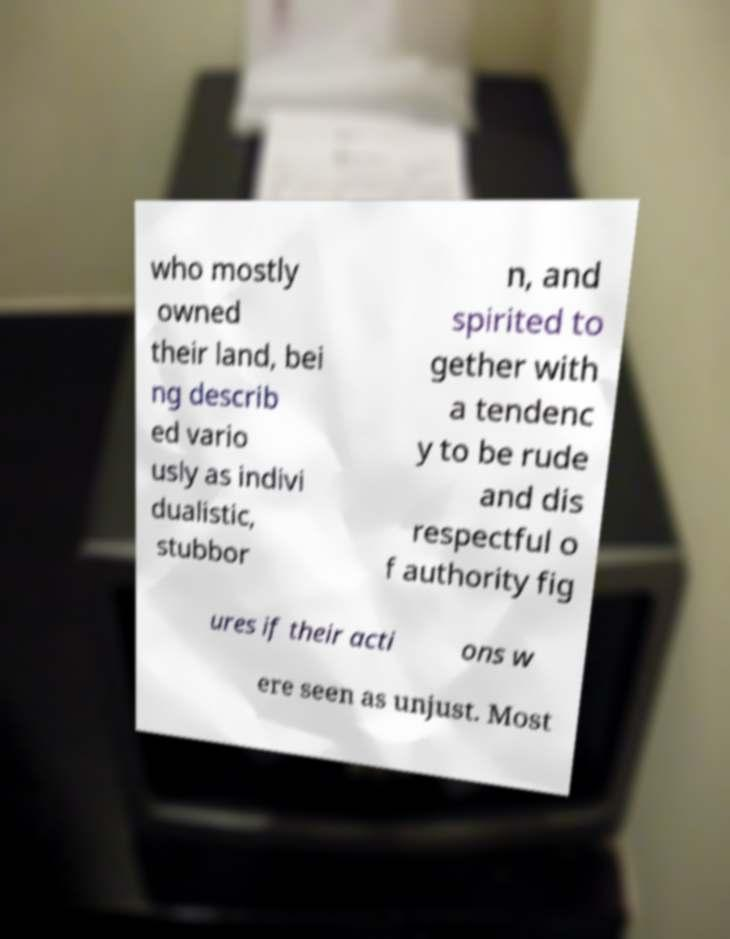What messages or text are displayed in this image? I need them in a readable, typed format. who mostly owned their land, bei ng describ ed vario usly as indivi dualistic, stubbor n, and spirited to gether with a tendenc y to be rude and dis respectful o f authority fig ures if their acti ons w ere seen as unjust. Most 